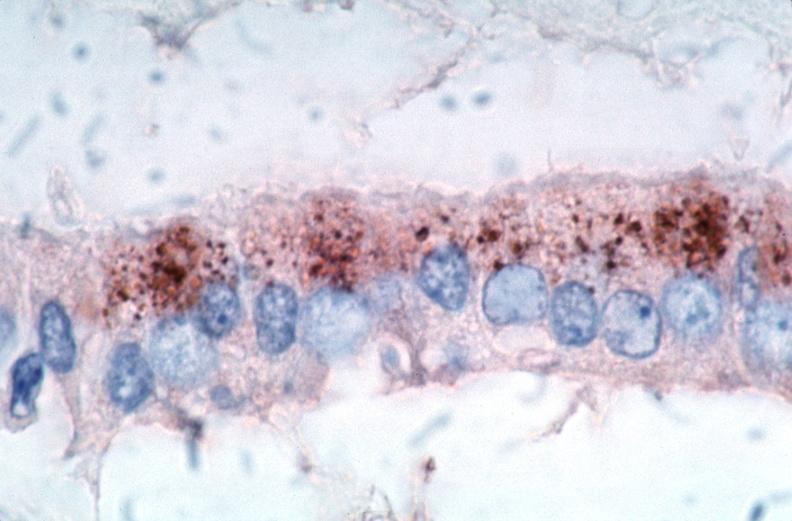s atrophy spotted fever, immunoperoxidase staining vessels for rickettsia rickettsii?
Answer the question using a single word or phrase. No 